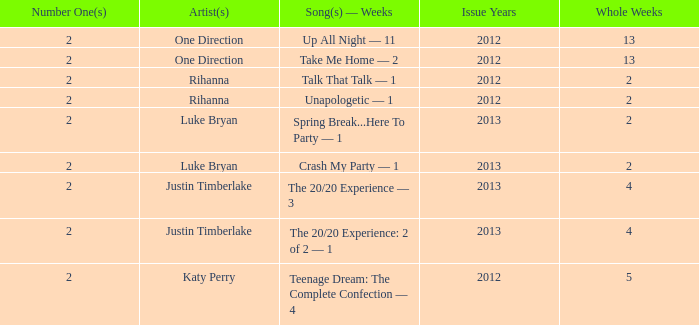What is the record for the most weeks any one song has been ranked at number #1? 13.0. 